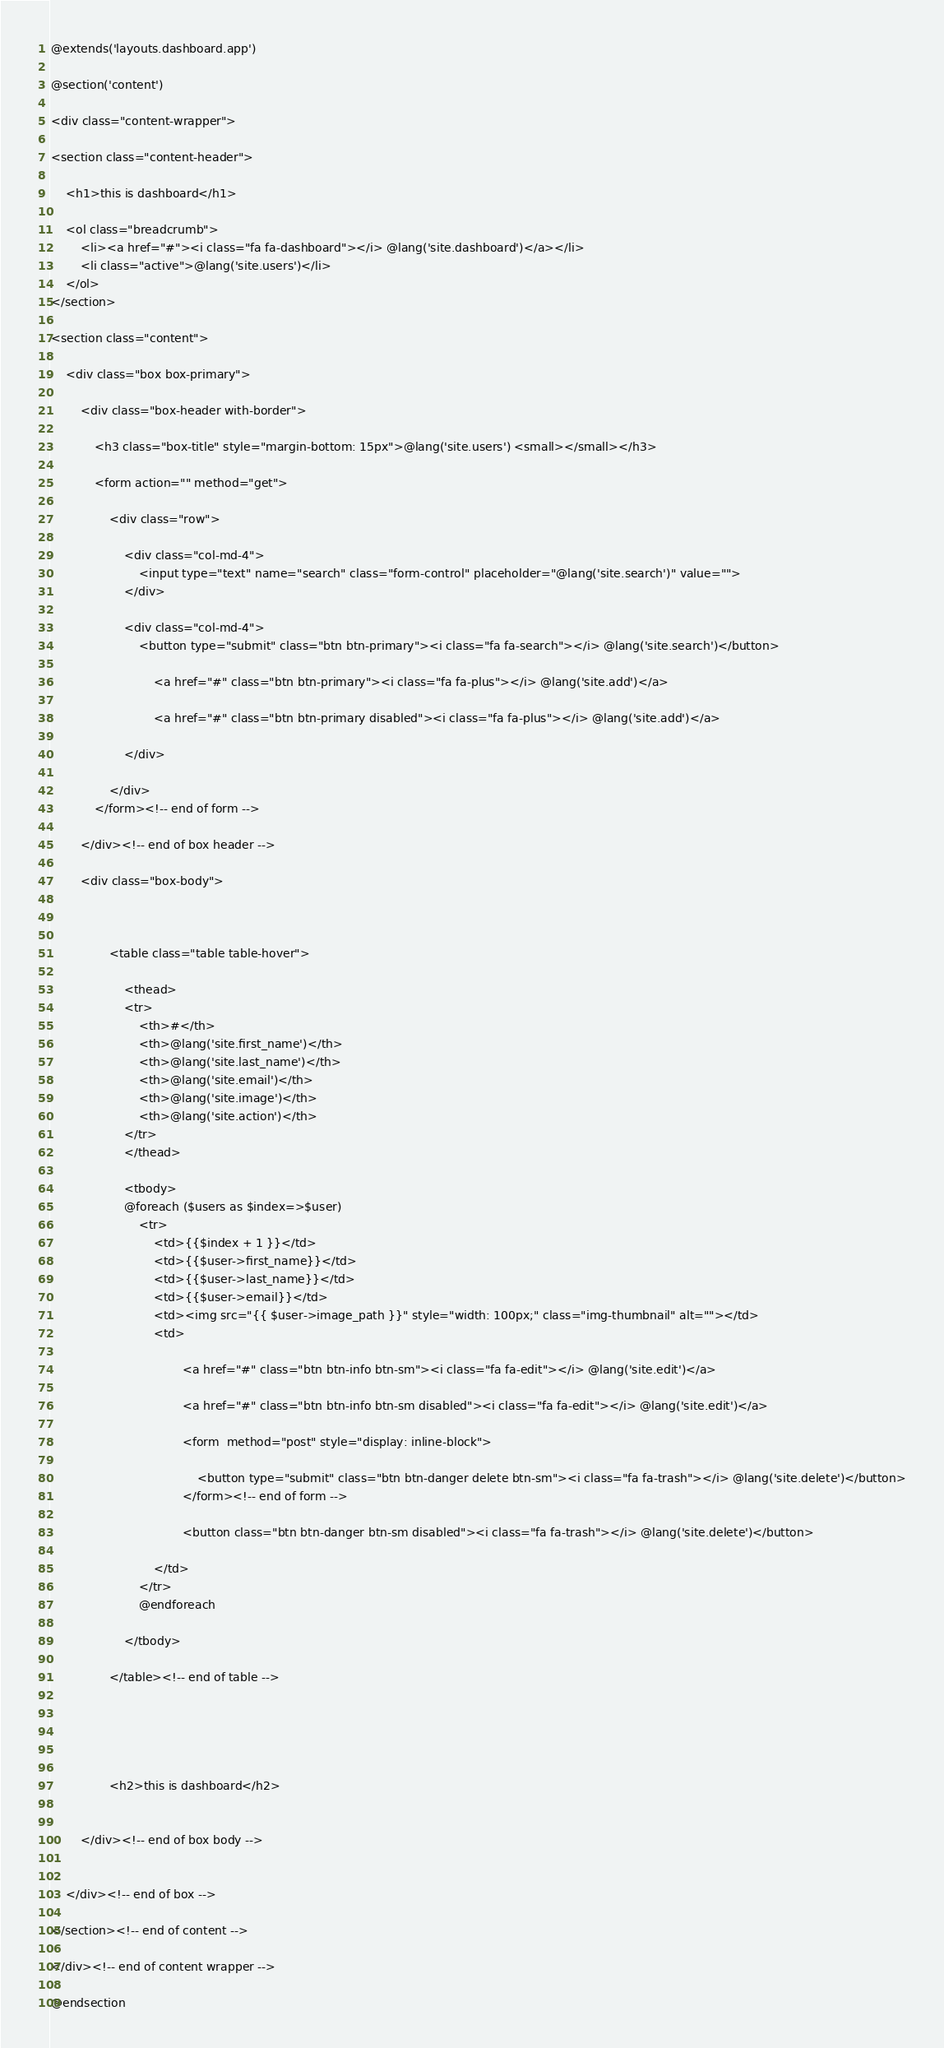<code> <loc_0><loc_0><loc_500><loc_500><_PHP_>@extends('layouts.dashboard.app')

@section('content')

<div class="content-wrapper">

<section class="content-header">

    <h1>this is dashboard</h1>

    <ol class="breadcrumb">
        <li><a href="#"><i class="fa fa-dashboard"></i> @lang('site.dashboard')</a></li>
        <li class="active">@lang('site.users')</li>
    </ol>
</section>

<section class="content">

    <div class="box box-primary">

        <div class="box-header with-border">

            <h3 class="box-title" style="margin-bottom: 15px">@lang('site.users') <small></small></h3>

            <form action="" method="get">

                <div class="row">

                    <div class="col-md-4">
                        <input type="text" name="search" class="form-control" placeholder="@lang('site.search')" value="">
                    </div>

                    <div class="col-md-4">
                        <button type="submit" class="btn btn-primary"><i class="fa fa-search"></i> @lang('site.search')</button>
                       
                            <a href="#" class="btn btn-primary"><i class="fa fa-plus"></i> @lang('site.add')</a>
                     
                            <a href="#" class="btn btn-primary disabled"><i class="fa fa-plus"></i> @lang('site.add')</a>
                     
                    </div>

                </div>
            </form><!-- end of form -->

        </div><!-- end of box header -->

        <div class="box-body">

     

                <table class="table table-hover">

                    <thead>
                    <tr>
                        <th>#</th>
                        <th>@lang('site.first_name')</th>
                        <th>@lang('site.last_name')</th>
                        <th>@lang('site.email')</th>
                        <th>@lang('site.image')</th>
                        <th>@lang('site.action')</th>
                    </tr>
                    </thead>
                    
                    <tbody>
                    @foreach ($users as $index=>$user)
                        <tr>
                            <td>{{$index + 1 }}</td>
                            <td>{{$user->first_name}}</td>
                            <td>{{$user->last_name}}</td>
                            <td>{{$user->email}}</td>
                            <td><img src="{{ $user->image_path }}" style="width: 100px;" class="img-thumbnail" alt=""></td>
                            <td>
                              
                                    <a href="#" class="btn btn-info btn-sm"><i class="fa fa-edit"></i> @lang('site.edit')</a>
                              
                                    <a href="#" class="btn btn-info btn-sm disabled"><i class="fa fa-edit"></i> @lang('site.edit')</a>
                            
                                    <form  method="post" style="display: inline-block">
                                       
                                        <button type="submit" class="btn btn-danger delete btn-sm"><i class="fa fa-trash"></i> @lang('site.delete')</button>
                                    </form><!-- end of form -->
                            
                                    <button class="btn btn-danger btn-sm disabled"><i class="fa fa-trash"></i> @lang('site.delete')</button>
                        
                            </td>
                        </tr>
                        @endforeach
              
                    </tbody>

                </table><!-- end of table -->
                
             
                
        
                
                <h2>this is dashboard</h2>
          

        </div><!-- end of box body -->


    </div><!-- end of box -->

</section><!-- end of content -->

</div><!-- end of content wrapper -->

@endsection</code> 